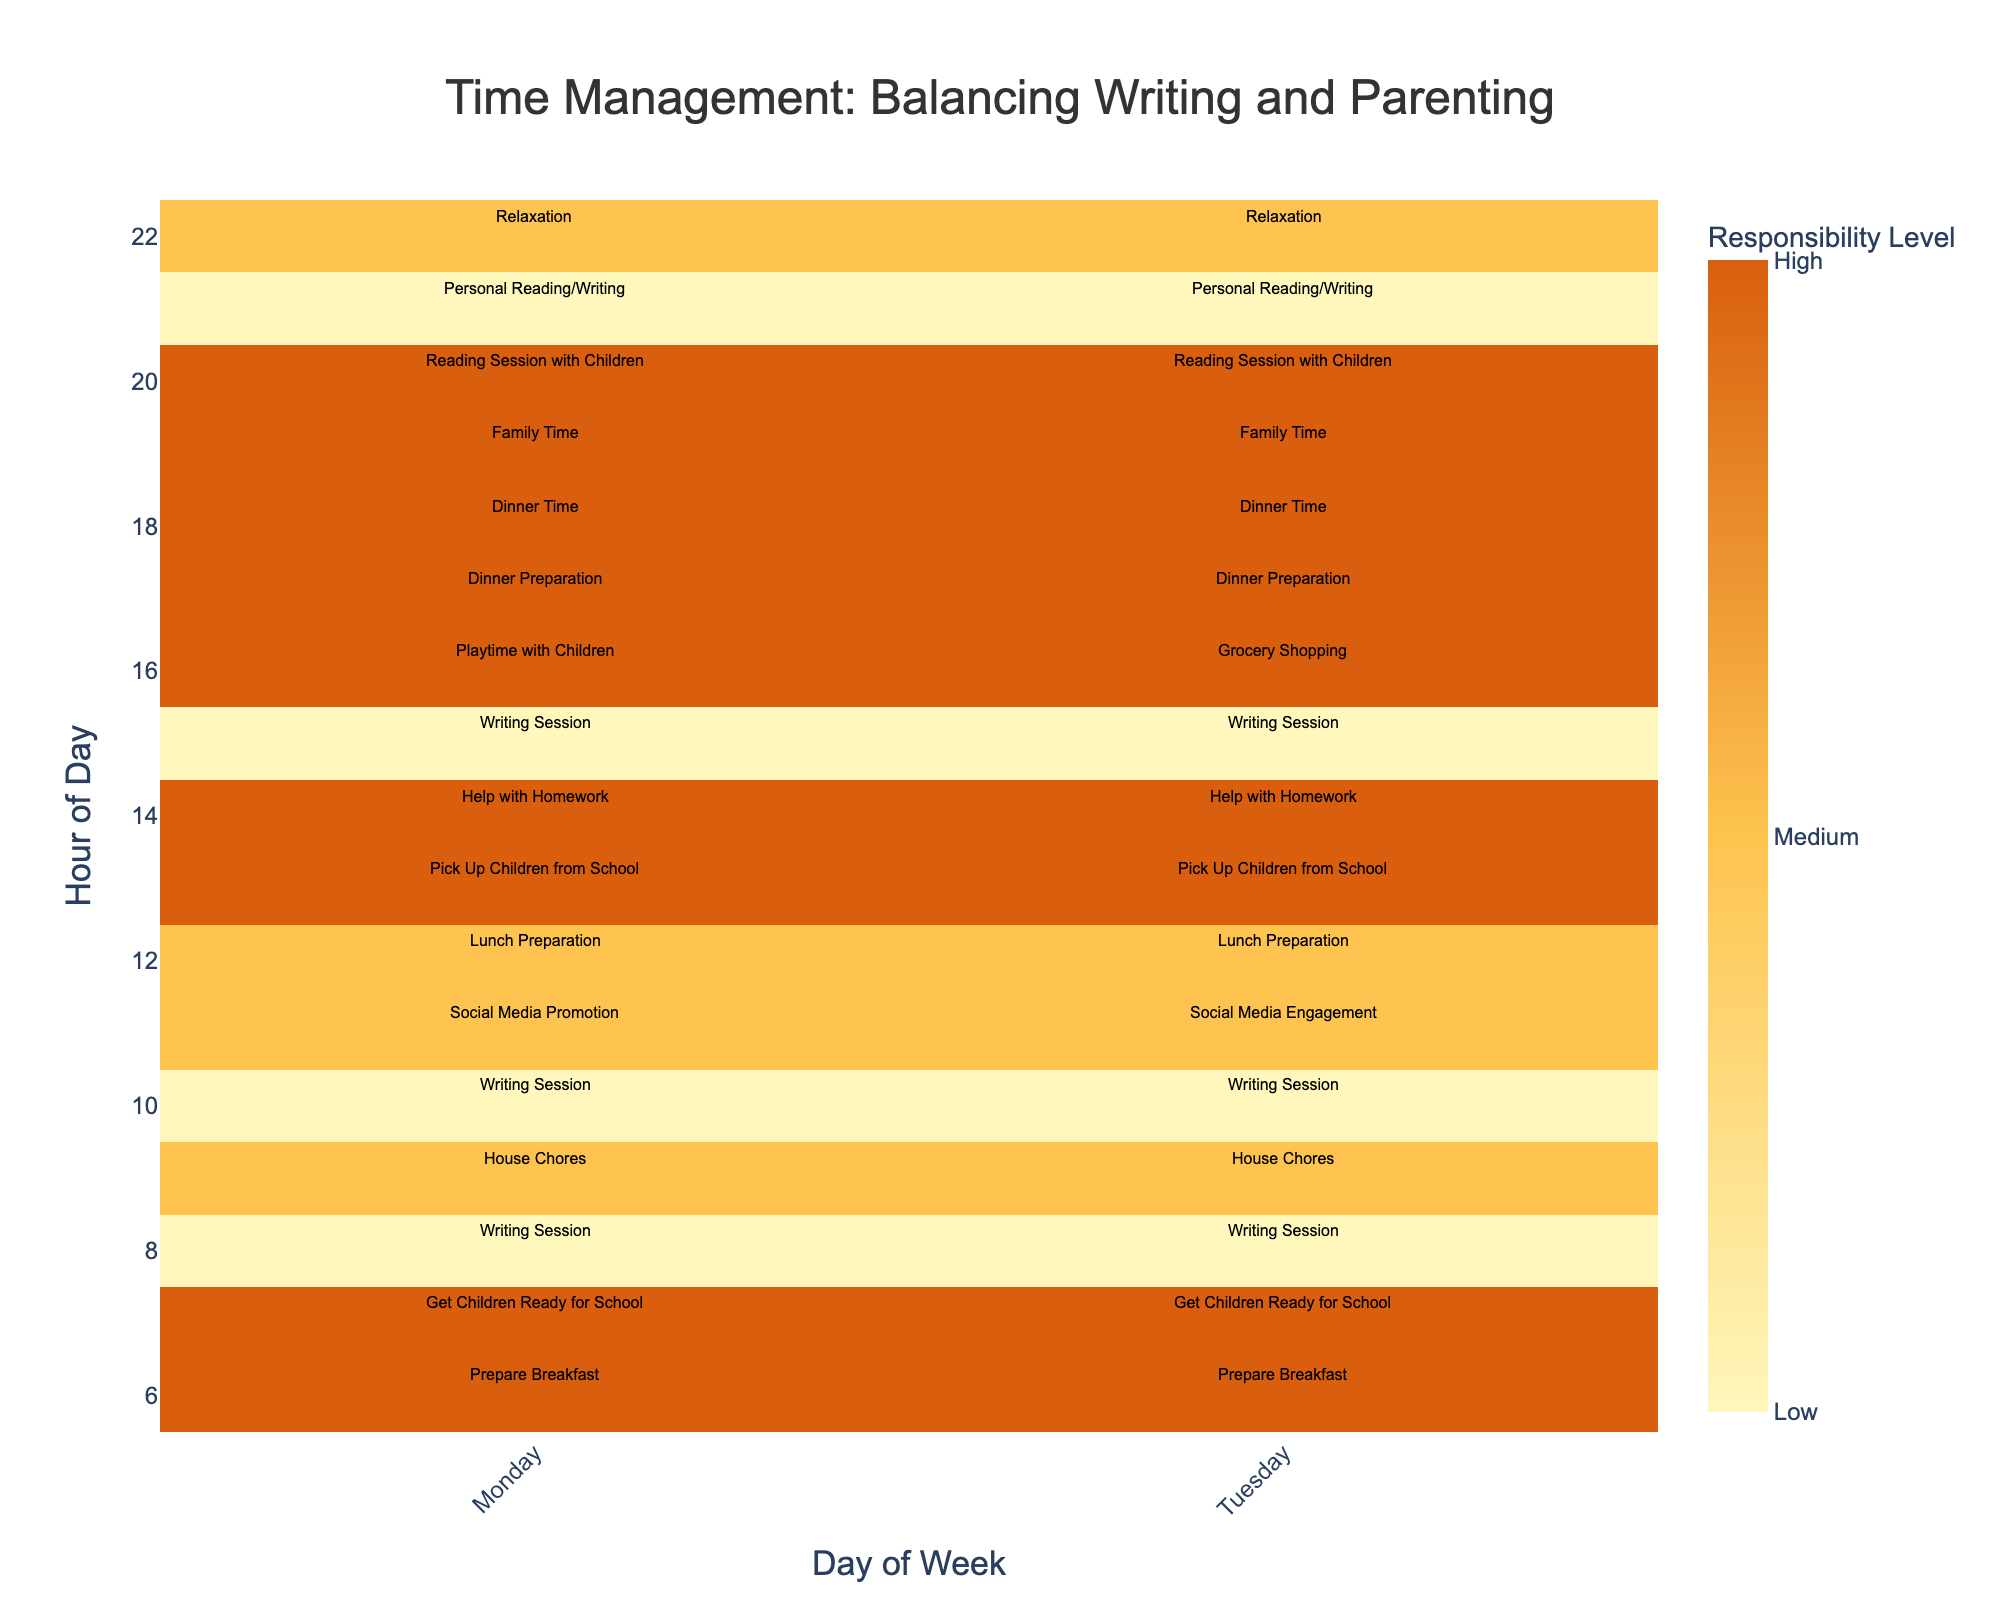What is the title of the heatmap? The title of a plot is usually found at the top and summarizes the main idea of the data. In this heatmap, the title is displayed at the top center.
Answer: Time Management: Balancing Writing and Parenting At what time is the responsibility level highest on Monday? To find the time with the highest responsibility level on Monday, look for the darkest colored squares (High) in the Monday column. Noting the times, we see that the levels are highest at several hours: 6, 7, 13, 16, 17, 18, 19, and 20.
Answer: Multiple times: 6, 7, 13, 16, 17, 18, 19, and 20 Which hours have medium responsibility levels on Tuesday? Find all the medium-colored squares (Medium) in the Tuesday column. These correspond to moderately responsible activities. Checking the times, Medium responsibility levels appear at 9, 11, 12, and 22.
Answer: 9, 11, 12, 22 Compare the writing sessions' frequency and responsibility levels between Monday and Tuesday. Which day has more writing sessions and how do they compare in responsibility? First, count the writing sessions (marked "Writing Session") for both days. Then determine their responsibility levels. Monday has writing sessions at 8, 10, 15, and 21 - all with Low responsibility. Tuesday also has writing sessions at 8, 10, 15, and 21 - again all with Low responsibility. Monday and Tuesday both have 4 writing sessions, all with the same level of responsibility.
Answer: Both days have 4 writing sessions, all with Low responsibility What activity has a low responsibility level and at what times does it occur? Looking at the heatmap, identify the lightest colored segments representing Low responsibility levels. These activities and their times are Writing Sessions (8, 10, 15, 21) and Personal Reading/Writing (21).
Answer: Writing Sessions: 8, 10, 15, 21; Personal Reading/Writing: 21 How does lunch preparation's responsibility level compare between Monday and Tuesday? Identify the segments labeled "Lunch Preparation" on both days, and compare their colors, which indicate responsibility levels. Both Monday and Tuesday show medium colored segments at 12.
Answer: Both at Medium level Which hour on Monday has the highest diversity in activities? Check the annotations on the Monday column to find the hour with the highest variety of different activities. Inspection shows that from 8 to 22, nearly every hour has a different activity.
Answer: Hours 8 to 22 have diverse activities On which day does grocery shopping take place, and what is its responsibility level? Locate the activity "Grocery Shopping" to see which day column it is in and note its color to understand its responsibility level. The activity is on Tuesday at 16 with a High responsibility level.
Answer: Tuesday, High What is the average responsibility level for activities on Monday at noon? First, identify the activities at 12 on Monday, which is "Lunch Preparation" with a Medium level (value of 2). Since there's only one activity, the average responsibility level for this hour is 2.
Answer: 2 